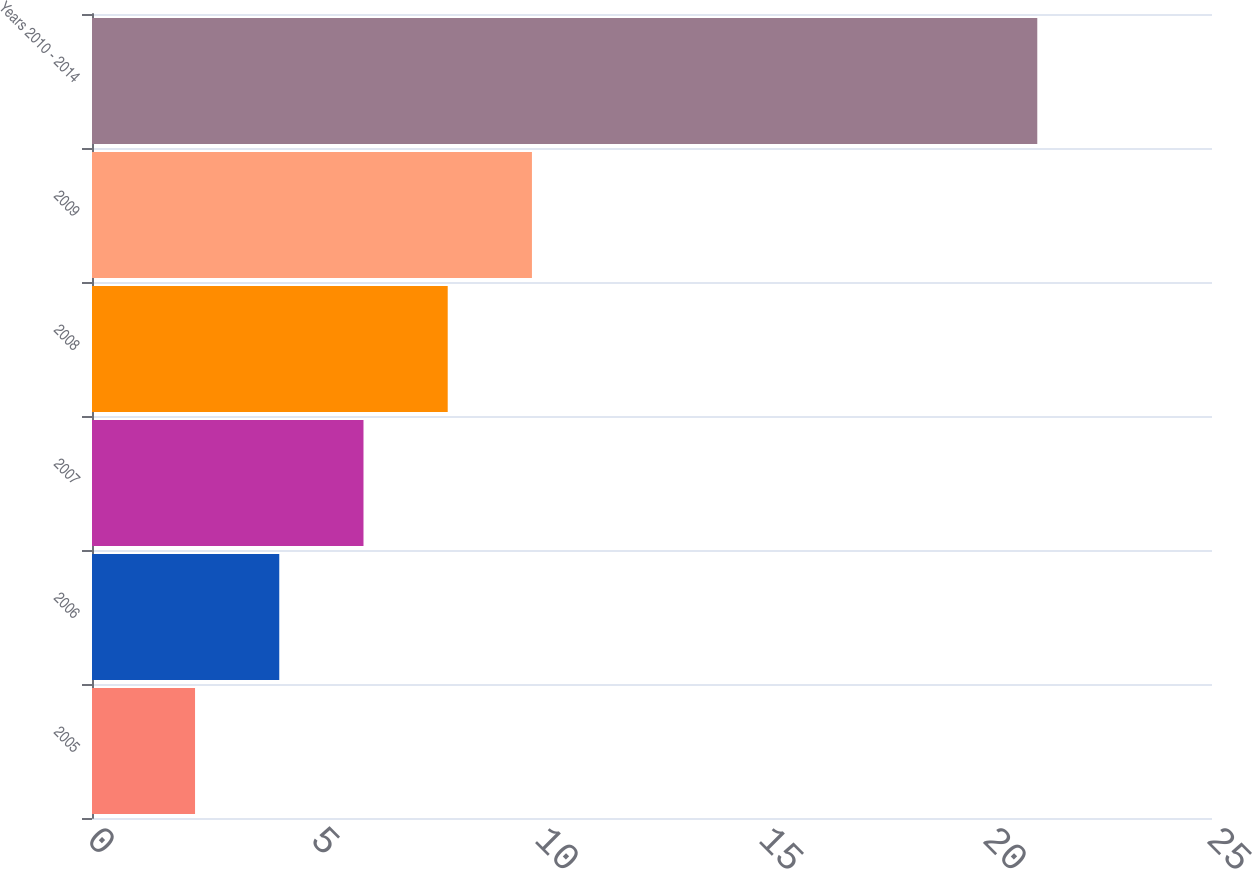<chart> <loc_0><loc_0><loc_500><loc_500><bar_chart><fcel>2005<fcel>2006<fcel>2007<fcel>2008<fcel>2009<fcel>Years 2010 - 2014<nl><fcel>2.3<fcel>4.18<fcel>6.06<fcel>7.94<fcel>9.82<fcel>21.1<nl></chart> 